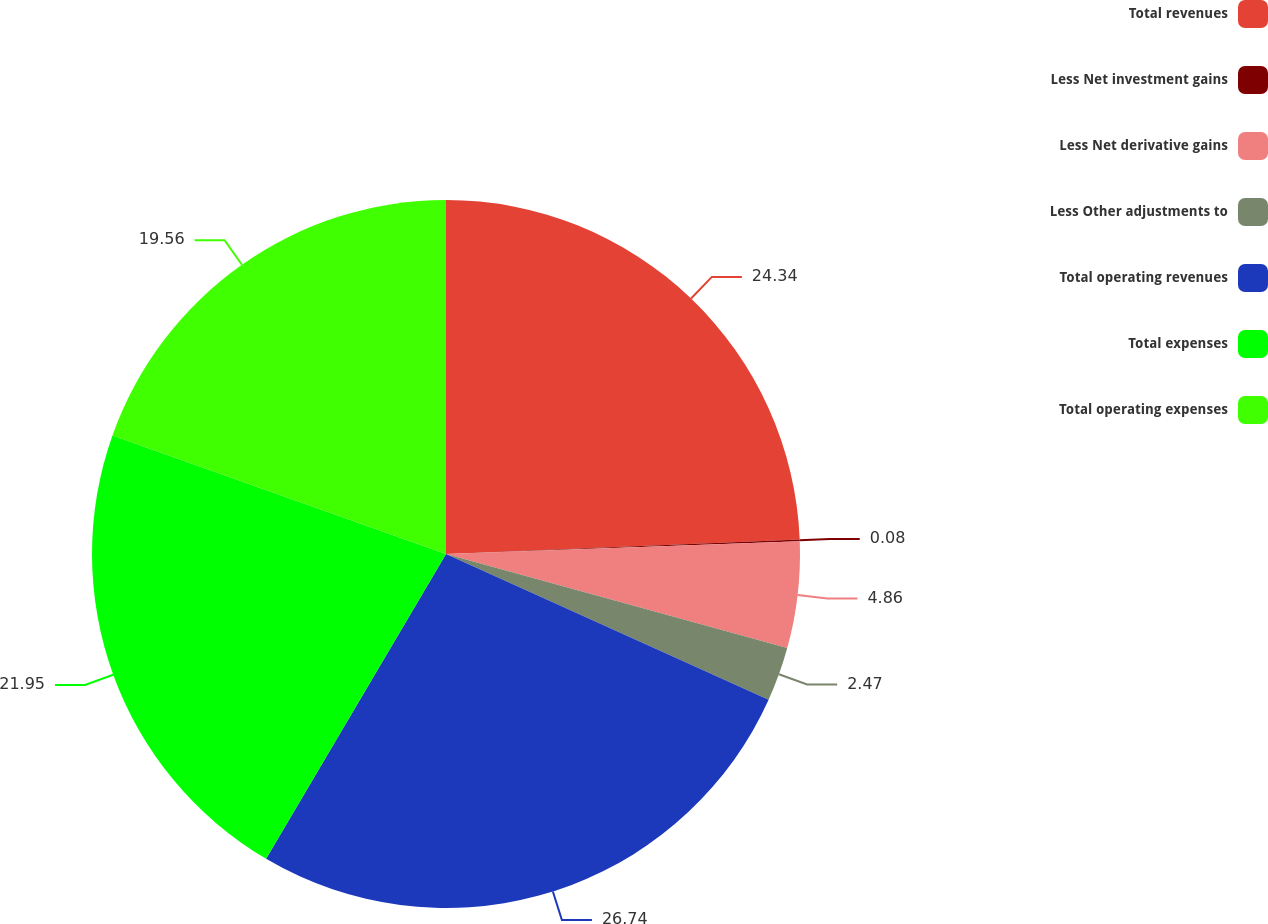<chart> <loc_0><loc_0><loc_500><loc_500><pie_chart><fcel>Total revenues<fcel>Less Net investment gains<fcel>Less Net derivative gains<fcel>Less Other adjustments to<fcel>Total operating revenues<fcel>Total expenses<fcel>Total operating expenses<nl><fcel>24.34%<fcel>0.08%<fcel>4.86%<fcel>2.47%<fcel>26.73%<fcel>21.95%<fcel>19.56%<nl></chart> 